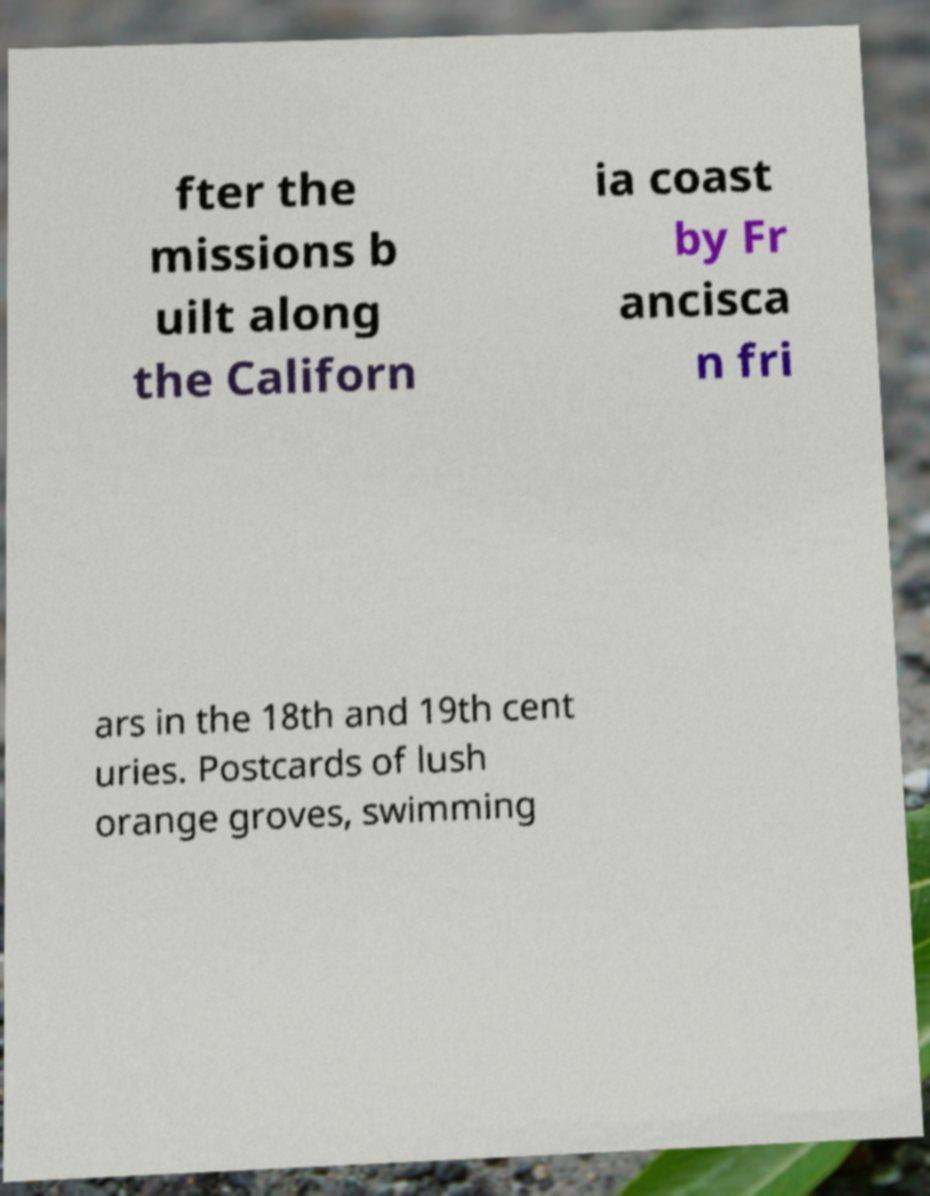Please identify and transcribe the text found in this image. fter the missions b uilt along the Californ ia coast by Fr ancisca n fri ars in the 18th and 19th cent uries. Postcards of lush orange groves, swimming 